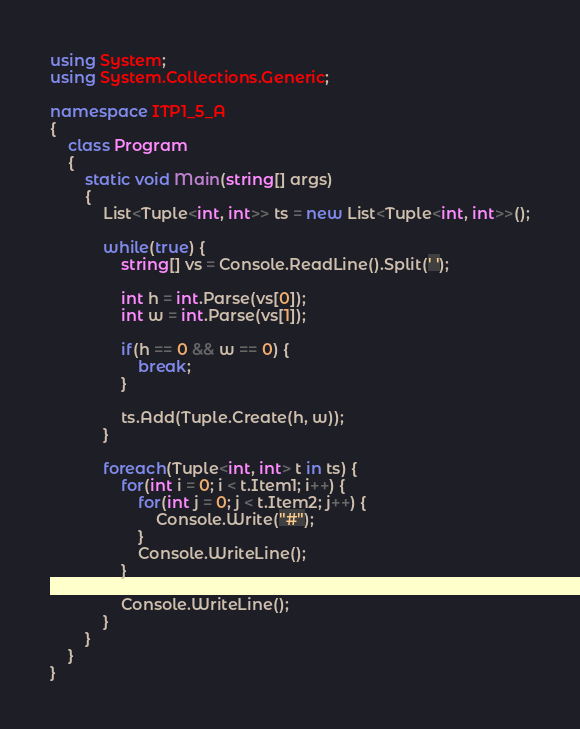Convert code to text. <code><loc_0><loc_0><loc_500><loc_500><_C#_>using System;
using System.Collections.Generic;

namespace ITP1_5_A
{
	class Program
	{
		static void Main(string[] args)
		{
			List<Tuple<int, int>> ts = new List<Tuple<int, int>>();

			while(true) {
				string[] vs = Console.ReadLine().Split(' ');

				int h = int.Parse(vs[0]);
				int w = int.Parse(vs[1]);

				if(h == 0 && w == 0) {
					break;
				}

				ts.Add(Tuple.Create(h, w));
			}

			foreach(Tuple<int, int> t in ts) {
				for(int i = 0; i < t.Item1; i++) {
					for(int j = 0; j < t.Item2; j++) {
						Console.Write("#");
					}
					Console.WriteLine();
				}

				Console.WriteLine();
			}
		}
	}
}

</code> 